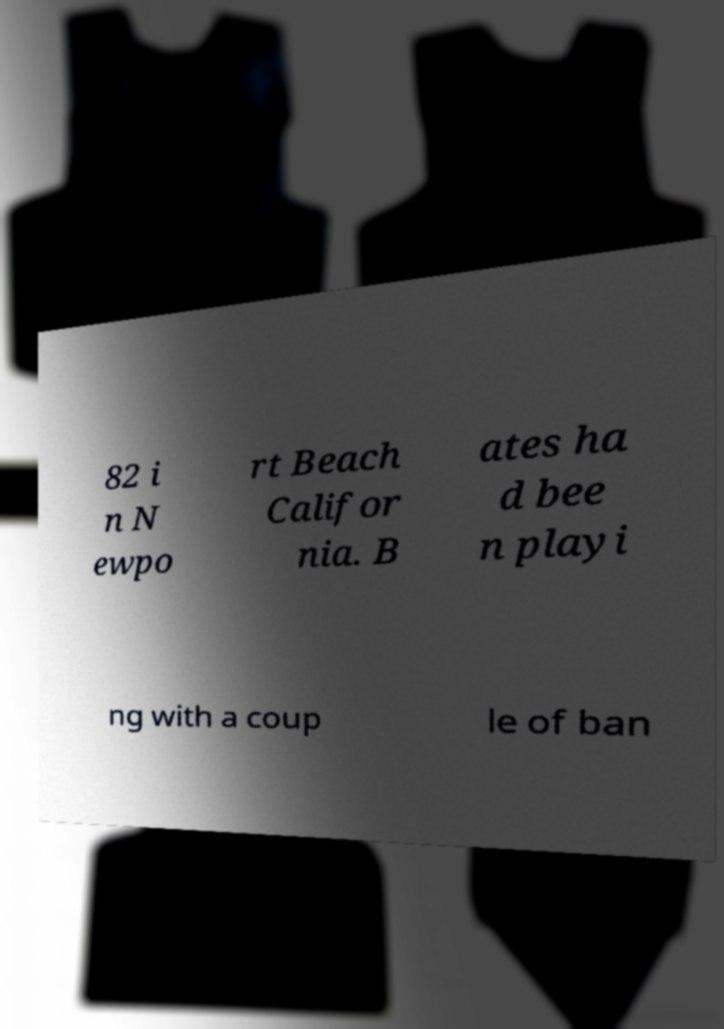Could you extract and type out the text from this image? 82 i n N ewpo rt Beach Califor nia. B ates ha d bee n playi ng with a coup le of ban 